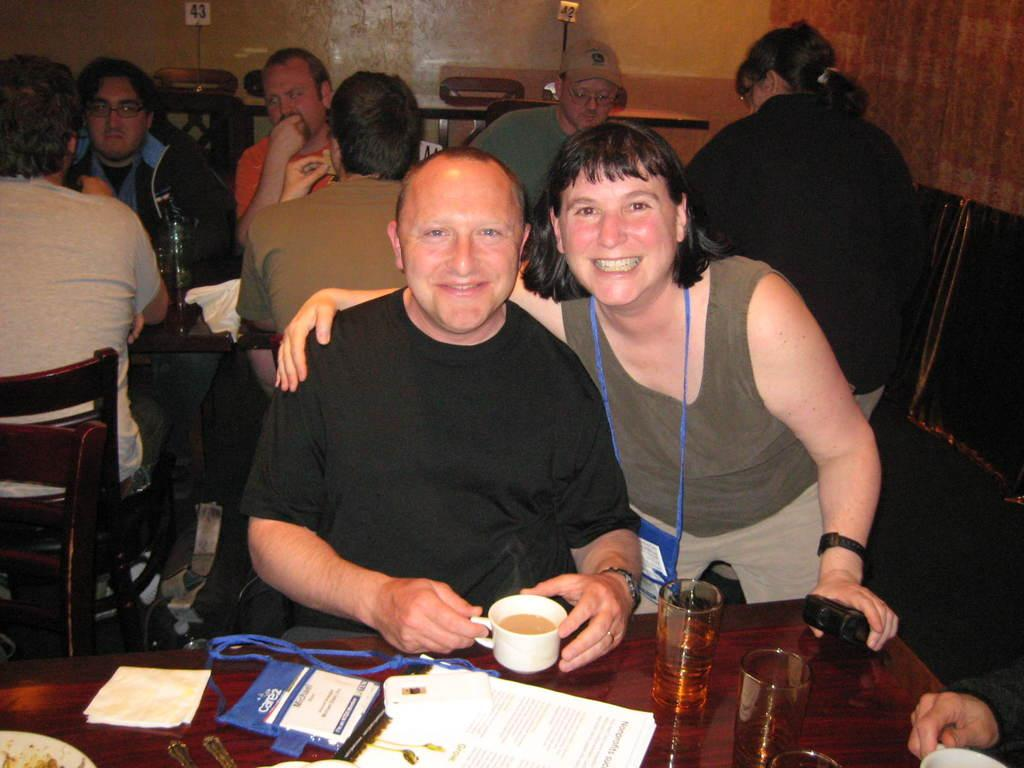What are the people in the image doing? The people in the image are sitting on chairs near a table. What objects can be seen on the table? There are glasses, a bookplate, an identity card, and a cup on the table. What might the people be using the glasses for? The glasses on the table might be used for drinking or holding other items. What is the purpose of the bookplate on the table? The bookplate on the table might be used to mark ownership or indicate the book's title. What type of magic trick is being performed with the cup on the table? There is no magic trick being performed in the image; the cup is simply sitting on the table. 